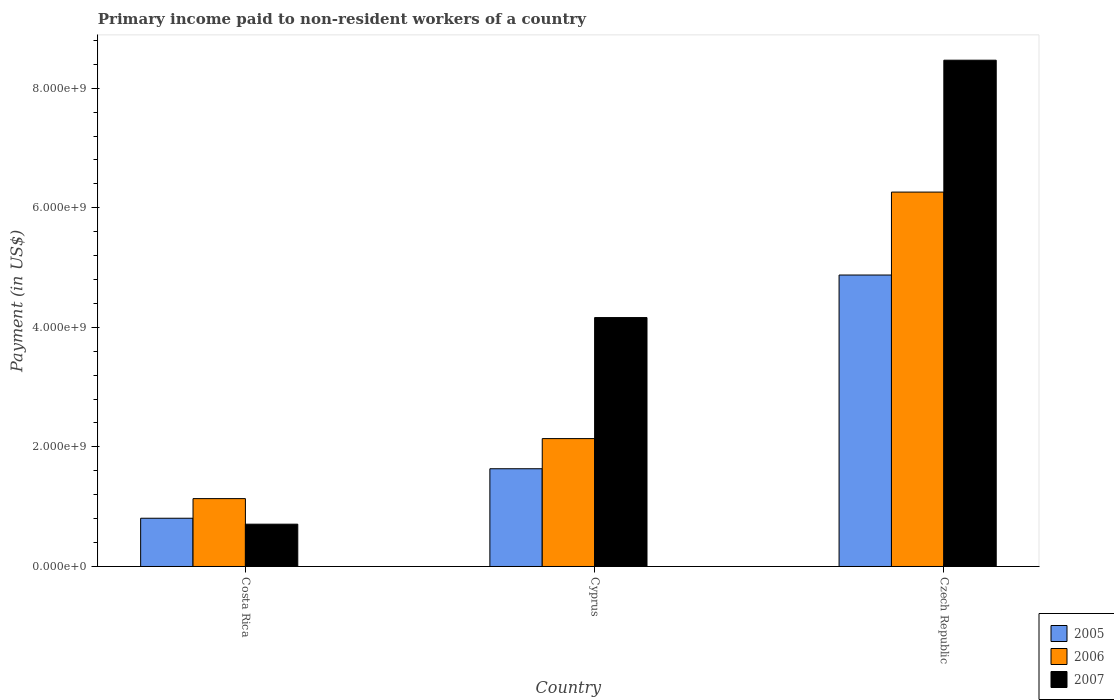How many groups of bars are there?
Make the answer very short. 3. Are the number of bars per tick equal to the number of legend labels?
Offer a very short reply. Yes. What is the label of the 2nd group of bars from the left?
Offer a terse response. Cyprus. In how many cases, is the number of bars for a given country not equal to the number of legend labels?
Make the answer very short. 0. What is the amount paid to workers in 2007 in Costa Rica?
Your response must be concise. 7.08e+08. Across all countries, what is the maximum amount paid to workers in 2005?
Provide a succinct answer. 4.87e+09. Across all countries, what is the minimum amount paid to workers in 2007?
Your response must be concise. 7.08e+08. In which country was the amount paid to workers in 2007 maximum?
Provide a short and direct response. Czech Republic. In which country was the amount paid to workers in 2005 minimum?
Offer a terse response. Costa Rica. What is the total amount paid to workers in 2007 in the graph?
Provide a succinct answer. 1.33e+1. What is the difference between the amount paid to workers in 2006 in Costa Rica and that in Czech Republic?
Give a very brief answer. -5.13e+09. What is the difference between the amount paid to workers in 2005 in Cyprus and the amount paid to workers in 2007 in Czech Republic?
Provide a short and direct response. -6.83e+09. What is the average amount paid to workers in 2007 per country?
Your answer should be very brief. 4.45e+09. What is the difference between the amount paid to workers of/in 2007 and amount paid to workers of/in 2006 in Cyprus?
Your answer should be very brief. 2.02e+09. What is the ratio of the amount paid to workers in 2005 in Costa Rica to that in Cyprus?
Your answer should be very brief. 0.49. Is the amount paid to workers in 2006 in Cyprus less than that in Czech Republic?
Your response must be concise. Yes. Is the difference between the amount paid to workers in 2007 in Cyprus and Czech Republic greater than the difference between the amount paid to workers in 2006 in Cyprus and Czech Republic?
Offer a terse response. No. What is the difference between the highest and the second highest amount paid to workers in 2006?
Give a very brief answer. -5.13e+09. What is the difference between the highest and the lowest amount paid to workers in 2006?
Your response must be concise. 5.13e+09. In how many countries, is the amount paid to workers in 2006 greater than the average amount paid to workers in 2006 taken over all countries?
Your response must be concise. 1. Is the sum of the amount paid to workers in 2006 in Costa Rica and Czech Republic greater than the maximum amount paid to workers in 2005 across all countries?
Your response must be concise. Yes. What does the 3rd bar from the left in Cyprus represents?
Offer a very short reply. 2007. What does the 2nd bar from the right in Cyprus represents?
Your response must be concise. 2006. Is it the case that in every country, the sum of the amount paid to workers in 2006 and amount paid to workers in 2005 is greater than the amount paid to workers in 2007?
Your answer should be compact. No. How many bars are there?
Offer a very short reply. 9. Are all the bars in the graph horizontal?
Your answer should be very brief. No. How many countries are there in the graph?
Offer a terse response. 3. What is the difference between two consecutive major ticks on the Y-axis?
Make the answer very short. 2.00e+09. How many legend labels are there?
Your answer should be very brief. 3. How are the legend labels stacked?
Provide a short and direct response. Vertical. What is the title of the graph?
Your answer should be compact. Primary income paid to non-resident workers of a country. What is the label or title of the Y-axis?
Your response must be concise. Payment (in US$). What is the Payment (in US$) in 2005 in Costa Rica?
Provide a short and direct response. 8.07e+08. What is the Payment (in US$) in 2006 in Costa Rica?
Your answer should be very brief. 1.14e+09. What is the Payment (in US$) of 2007 in Costa Rica?
Make the answer very short. 7.08e+08. What is the Payment (in US$) in 2005 in Cyprus?
Give a very brief answer. 1.63e+09. What is the Payment (in US$) of 2006 in Cyprus?
Offer a very short reply. 2.14e+09. What is the Payment (in US$) of 2007 in Cyprus?
Offer a very short reply. 4.16e+09. What is the Payment (in US$) in 2005 in Czech Republic?
Your response must be concise. 4.87e+09. What is the Payment (in US$) in 2006 in Czech Republic?
Give a very brief answer. 6.26e+09. What is the Payment (in US$) in 2007 in Czech Republic?
Your response must be concise. 8.47e+09. Across all countries, what is the maximum Payment (in US$) in 2005?
Your answer should be very brief. 4.87e+09. Across all countries, what is the maximum Payment (in US$) of 2006?
Ensure brevity in your answer.  6.26e+09. Across all countries, what is the maximum Payment (in US$) of 2007?
Ensure brevity in your answer.  8.47e+09. Across all countries, what is the minimum Payment (in US$) of 2005?
Provide a short and direct response. 8.07e+08. Across all countries, what is the minimum Payment (in US$) in 2006?
Provide a succinct answer. 1.14e+09. Across all countries, what is the minimum Payment (in US$) in 2007?
Provide a short and direct response. 7.08e+08. What is the total Payment (in US$) in 2005 in the graph?
Ensure brevity in your answer.  7.32e+09. What is the total Payment (in US$) in 2006 in the graph?
Your response must be concise. 9.54e+09. What is the total Payment (in US$) of 2007 in the graph?
Ensure brevity in your answer.  1.33e+1. What is the difference between the Payment (in US$) of 2005 in Costa Rica and that in Cyprus?
Ensure brevity in your answer.  -8.28e+08. What is the difference between the Payment (in US$) in 2006 in Costa Rica and that in Cyprus?
Offer a very short reply. -1.00e+09. What is the difference between the Payment (in US$) in 2007 in Costa Rica and that in Cyprus?
Keep it short and to the point. -3.46e+09. What is the difference between the Payment (in US$) of 2005 in Costa Rica and that in Czech Republic?
Provide a short and direct response. -4.07e+09. What is the difference between the Payment (in US$) of 2006 in Costa Rica and that in Czech Republic?
Ensure brevity in your answer.  -5.13e+09. What is the difference between the Payment (in US$) in 2007 in Costa Rica and that in Czech Republic?
Make the answer very short. -7.76e+09. What is the difference between the Payment (in US$) in 2005 in Cyprus and that in Czech Republic?
Make the answer very short. -3.24e+09. What is the difference between the Payment (in US$) in 2006 in Cyprus and that in Czech Republic?
Offer a terse response. -4.12e+09. What is the difference between the Payment (in US$) in 2007 in Cyprus and that in Czech Republic?
Offer a very short reply. -4.30e+09. What is the difference between the Payment (in US$) in 2005 in Costa Rica and the Payment (in US$) in 2006 in Cyprus?
Your answer should be very brief. -1.33e+09. What is the difference between the Payment (in US$) of 2005 in Costa Rica and the Payment (in US$) of 2007 in Cyprus?
Keep it short and to the point. -3.36e+09. What is the difference between the Payment (in US$) in 2006 in Costa Rica and the Payment (in US$) in 2007 in Cyprus?
Provide a short and direct response. -3.03e+09. What is the difference between the Payment (in US$) in 2005 in Costa Rica and the Payment (in US$) in 2006 in Czech Republic?
Offer a terse response. -5.46e+09. What is the difference between the Payment (in US$) of 2005 in Costa Rica and the Payment (in US$) of 2007 in Czech Republic?
Your answer should be compact. -7.66e+09. What is the difference between the Payment (in US$) of 2006 in Costa Rica and the Payment (in US$) of 2007 in Czech Republic?
Provide a short and direct response. -7.33e+09. What is the difference between the Payment (in US$) of 2005 in Cyprus and the Payment (in US$) of 2006 in Czech Republic?
Keep it short and to the point. -4.63e+09. What is the difference between the Payment (in US$) in 2005 in Cyprus and the Payment (in US$) in 2007 in Czech Republic?
Provide a short and direct response. -6.83e+09. What is the difference between the Payment (in US$) of 2006 in Cyprus and the Payment (in US$) of 2007 in Czech Republic?
Make the answer very short. -6.33e+09. What is the average Payment (in US$) in 2005 per country?
Your response must be concise. 2.44e+09. What is the average Payment (in US$) in 2006 per country?
Offer a terse response. 3.18e+09. What is the average Payment (in US$) in 2007 per country?
Your answer should be very brief. 4.45e+09. What is the difference between the Payment (in US$) in 2005 and Payment (in US$) in 2006 in Costa Rica?
Keep it short and to the point. -3.28e+08. What is the difference between the Payment (in US$) in 2005 and Payment (in US$) in 2007 in Costa Rica?
Your response must be concise. 9.92e+07. What is the difference between the Payment (in US$) of 2006 and Payment (in US$) of 2007 in Costa Rica?
Your answer should be compact. 4.27e+08. What is the difference between the Payment (in US$) in 2005 and Payment (in US$) in 2006 in Cyprus?
Give a very brief answer. -5.04e+08. What is the difference between the Payment (in US$) of 2005 and Payment (in US$) of 2007 in Cyprus?
Your answer should be compact. -2.53e+09. What is the difference between the Payment (in US$) of 2006 and Payment (in US$) of 2007 in Cyprus?
Provide a succinct answer. -2.02e+09. What is the difference between the Payment (in US$) in 2005 and Payment (in US$) in 2006 in Czech Republic?
Your answer should be very brief. -1.39e+09. What is the difference between the Payment (in US$) of 2005 and Payment (in US$) of 2007 in Czech Republic?
Offer a terse response. -3.59e+09. What is the difference between the Payment (in US$) in 2006 and Payment (in US$) in 2007 in Czech Republic?
Offer a terse response. -2.21e+09. What is the ratio of the Payment (in US$) in 2005 in Costa Rica to that in Cyprus?
Offer a terse response. 0.49. What is the ratio of the Payment (in US$) of 2006 in Costa Rica to that in Cyprus?
Offer a very short reply. 0.53. What is the ratio of the Payment (in US$) of 2007 in Costa Rica to that in Cyprus?
Make the answer very short. 0.17. What is the ratio of the Payment (in US$) of 2005 in Costa Rica to that in Czech Republic?
Provide a short and direct response. 0.17. What is the ratio of the Payment (in US$) of 2006 in Costa Rica to that in Czech Republic?
Your answer should be very brief. 0.18. What is the ratio of the Payment (in US$) in 2007 in Costa Rica to that in Czech Republic?
Offer a very short reply. 0.08. What is the ratio of the Payment (in US$) in 2005 in Cyprus to that in Czech Republic?
Your response must be concise. 0.34. What is the ratio of the Payment (in US$) in 2006 in Cyprus to that in Czech Republic?
Provide a short and direct response. 0.34. What is the ratio of the Payment (in US$) in 2007 in Cyprus to that in Czech Republic?
Your answer should be compact. 0.49. What is the difference between the highest and the second highest Payment (in US$) in 2005?
Provide a short and direct response. 3.24e+09. What is the difference between the highest and the second highest Payment (in US$) in 2006?
Ensure brevity in your answer.  4.12e+09. What is the difference between the highest and the second highest Payment (in US$) of 2007?
Give a very brief answer. 4.30e+09. What is the difference between the highest and the lowest Payment (in US$) in 2005?
Ensure brevity in your answer.  4.07e+09. What is the difference between the highest and the lowest Payment (in US$) of 2006?
Give a very brief answer. 5.13e+09. What is the difference between the highest and the lowest Payment (in US$) in 2007?
Provide a succinct answer. 7.76e+09. 